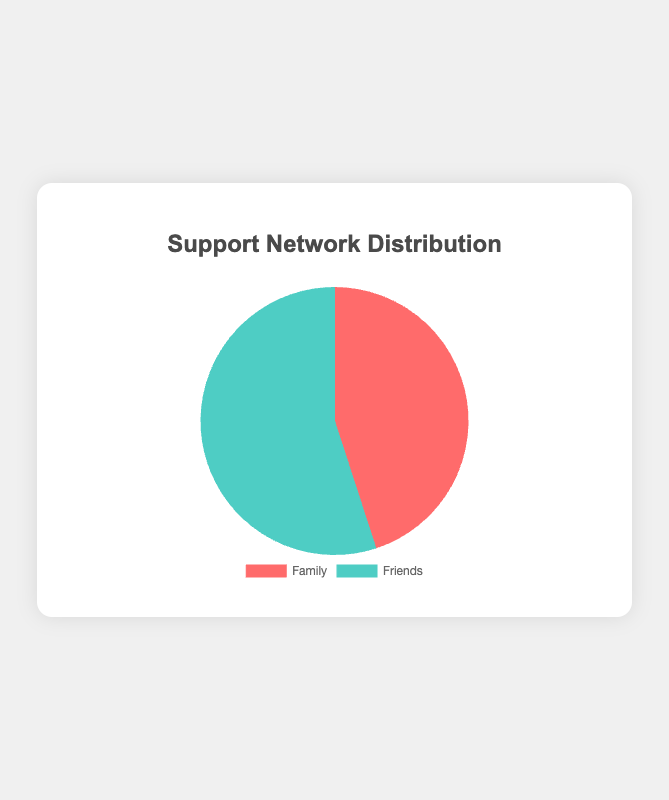What is the proportion of support from friends? According to the pie chart, the slice representing friends is 55% of the total chart.
Answer: 55% Which type of support is higher, Family or Friends? By observing the chart, the slice for friends is larger than that for family, indicating that support from friends is higher.
Answer: Friends What is the difference in proportions between support from family and friends? To find the difference, subtract the proportion of family support (45%) from the proportion of friends support (55%). So, 55% - 45% = 10%.
Answer: 10% What are the colors representing family and friends support in the chart? The pie chart uses different colors for each category: the color for family is red and for friends is green.
Answer: Red for family, green for friends What is the combined support from both family and friends? Combined support is the sum of both proportions: 45% from family + 55% from friends = 100%.
Answer: 100% If the total support is 100%, what proportion is left if we remove friends' support? Removing friends' support leaves the proportion of family support, which is 45% of the total.
Answer: 45% What proportion of the chart does the family support occupy? The family support occupies 45% of the chart, as indicated by the corresponding slice.
Answer: 45% How much larger is friends' support compared to family support? Subtract the proportion of family support from that of friends: 55% - 45% = 10%. Friends' support is 10% larger than family support.
Answer: 10% If the total support counts to 200 units, how many units of support come from friends? Calculate 55% of 200 units: 0.55 * 200 = 110 units.
Answer: 110 units Considering equal total support from family and friends, how would the chart visual change? If family and friends support were equal, each would be 50%, and the visual indication would show two equally sized slices.
Answer: Equally sized slices 